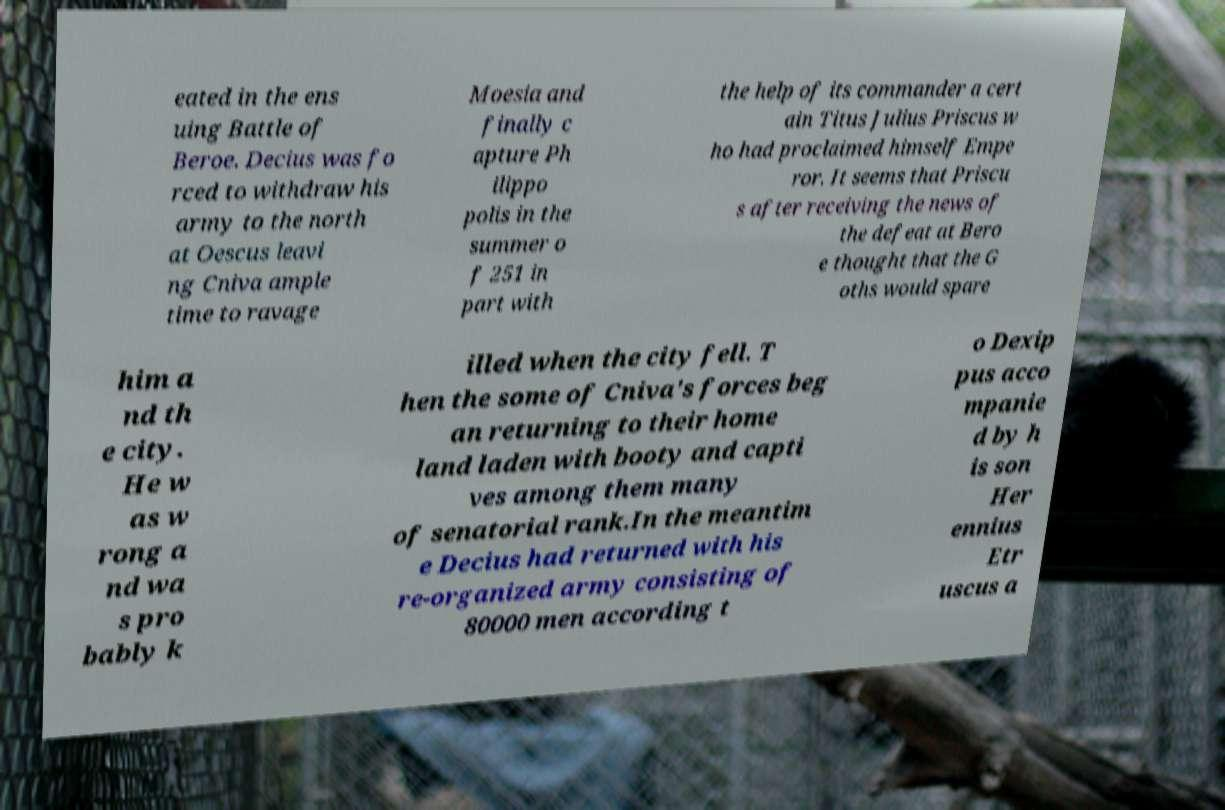There's text embedded in this image that I need extracted. Can you transcribe it verbatim? eated in the ens uing Battle of Beroe. Decius was fo rced to withdraw his army to the north at Oescus leavi ng Cniva ample time to ravage Moesia and finally c apture Ph ilippo polis in the summer o f 251 in part with the help of its commander a cert ain Titus Julius Priscus w ho had proclaimed himself Empe ror. It seems that Priscu s after receiving the news of the defeat at Bero e thought that the G oths would spare him a nd th e city. He w as w rong a nd wa s pro bably k illed when the city fell. T hen the some of Cniva's forces beg an returning to their home land laden with booty and capti ves among them many of senatorial rank.In the meantim e Decius had returned with his re-organized army consisting of 80000 men according t o Dexip pus acco mpanie d by h is son Her ennius Etr uscus a 